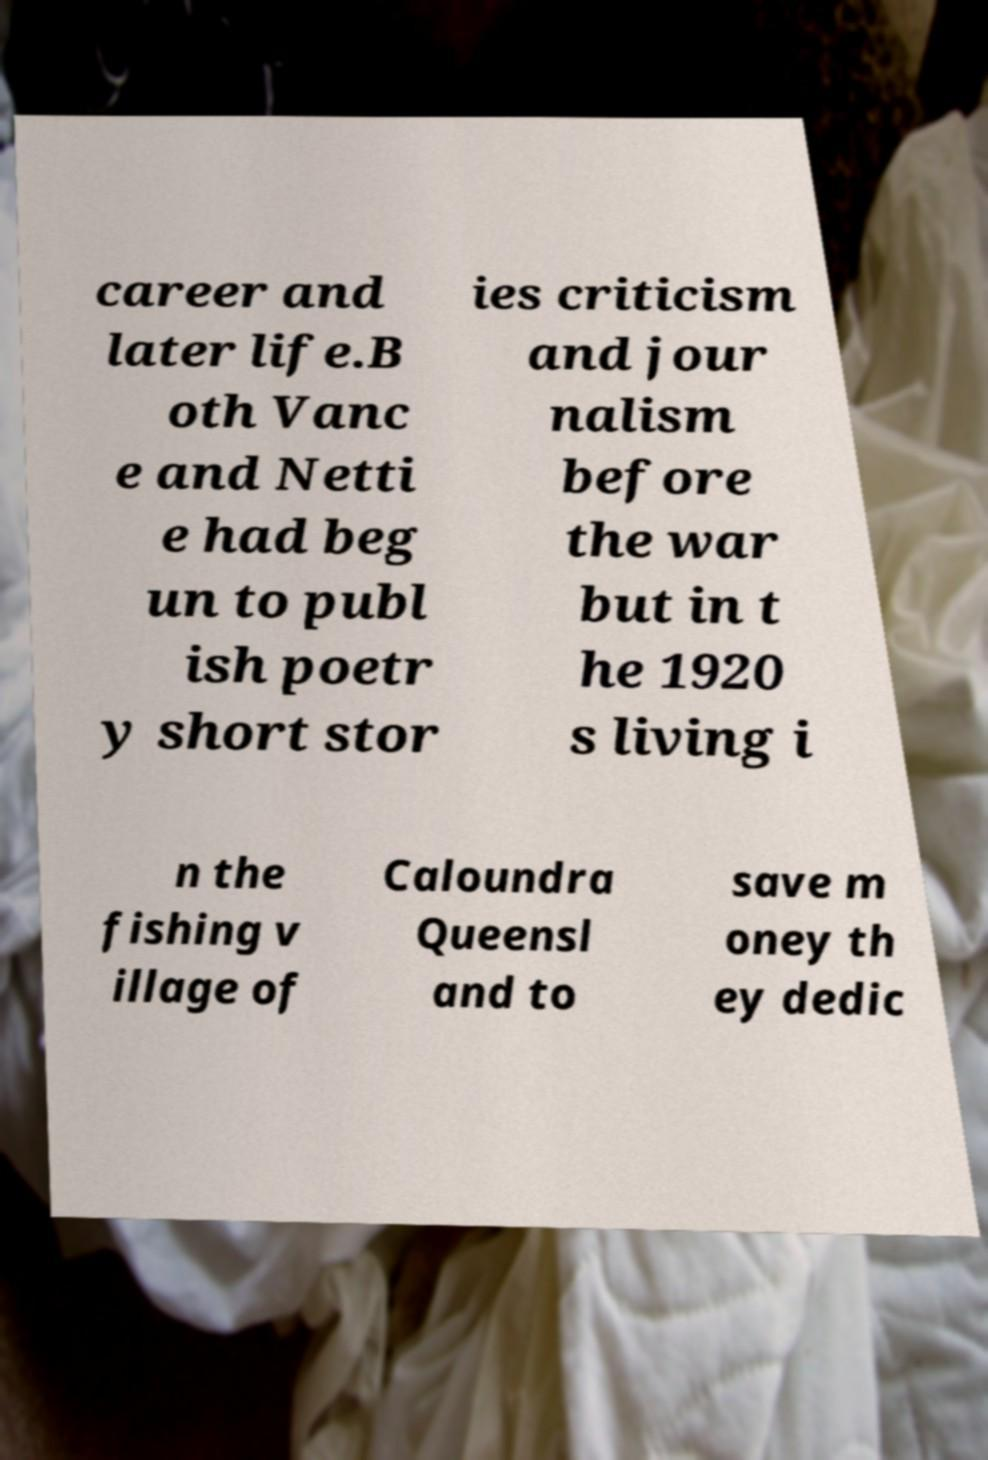Please identify and transcribe the text found in this image. career and later life.B oth Vanc e and Netti e had beg un to publ ish poetr y short stor ies criticism and jour nalism before the war but in t he 1920 s living i n the fishing v illage of Caloundra Queensl and to save m oney th ey dedic 